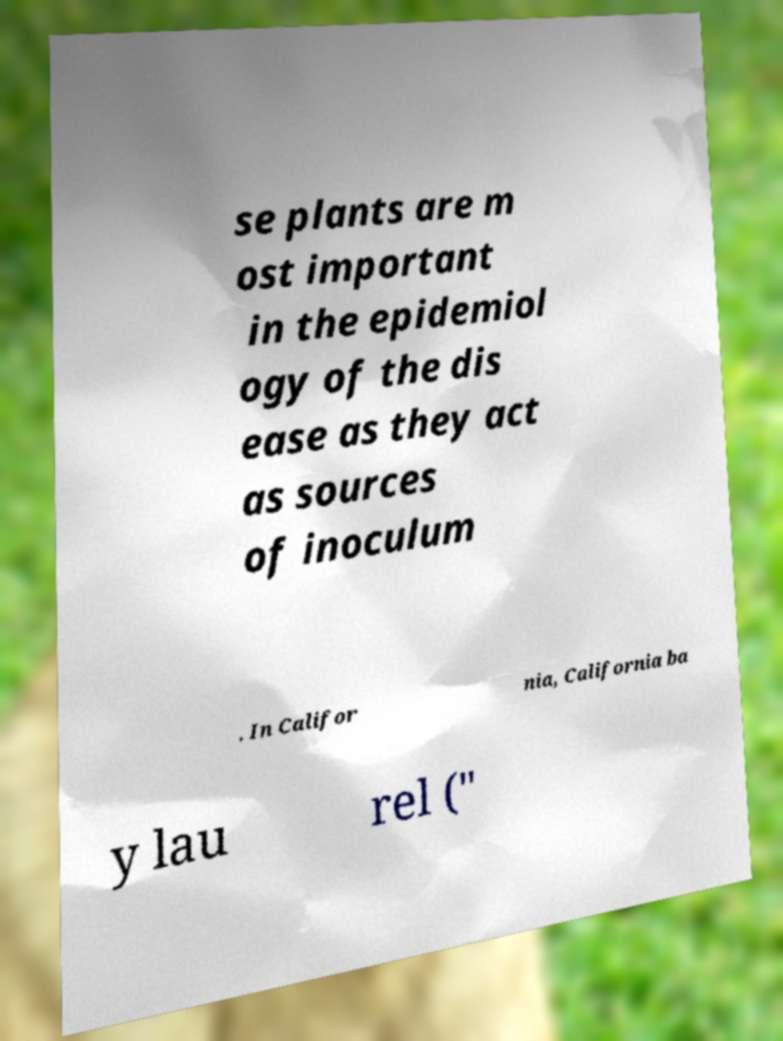What messages or text are displayed in this image? I need them in a readable, typed format. se plants are m ost important in the epidemiol ogy of the dis ease as they act as sources of inoculum . In Califor nia, California ba y lau rel (" 